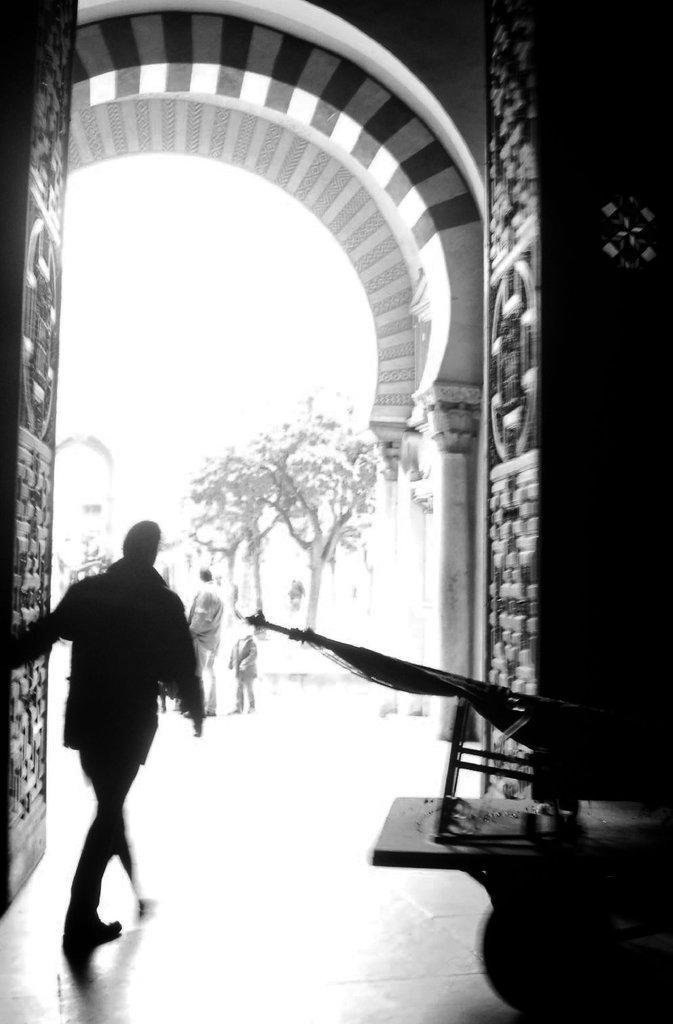Please provide a concise description of this image. This picture is in black and white. On the top, there is an entrance with a door. At the bottom left, there is a person. Towards the right, there is a tool. In the background, there are trees and people. 